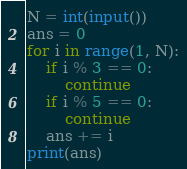<code> <loc_0><loc_0><loc_500><loc_500><_Python_>N = int(input())
ans = 0
for i in range(1, N):
    if i % 3 == 0:
        continue
    if i % 5 == 0:
        continue
    ans += i
print(ans)
</code> 